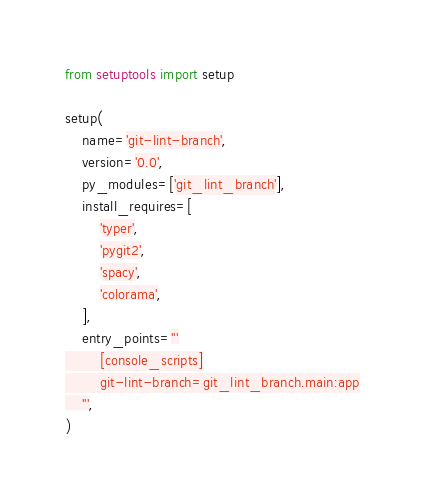<code> <loc_0><loc_0><loc_500><loc_500><_Python_>from setuptools import setup

setup(
    name='git-lint-branch',
    version='0.0',
    py_modules=['git_lint_branch'],
    install_requires=[
        'typer',
        'pygit2',
        'spacy',
        'colorama',
    ],
    entry_points='''
        [console_scripts]
        git-lint-branch=git_lint_branch.main:app
    ''',
)
</code> 